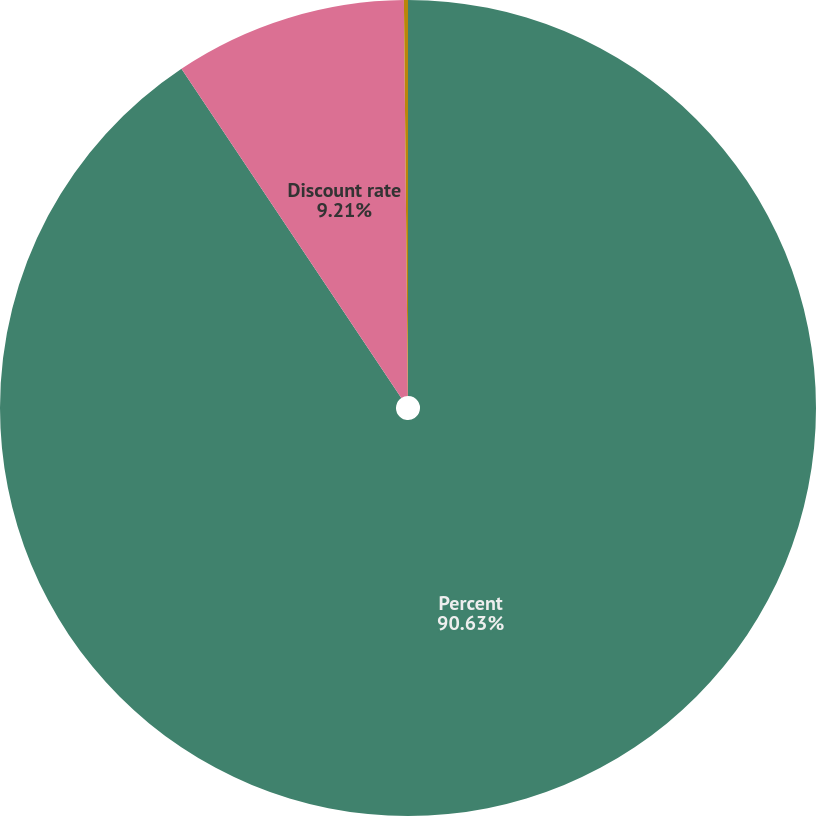Convert chart. <chart><loc_0><loc_0><loc_500><loc_500><pie_chart><fcel>Percent<fcel>Discount rate<fcel>Rate of compensation increase<nl><fcel>90.64%<fcel>9.21%<fcel>0.16%<nl></chart> 